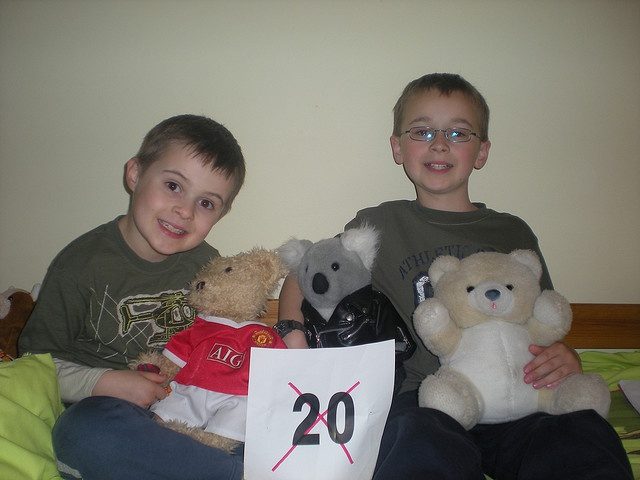Describe the objects in this image and their specific colors. I can see people in gray, black, and navy tones, people in gray and black tones, teddy bear in gray and darkgray tones, teddy bear in gray, brown, and darkgray tones, and teddy bear in gray, black, and darkgray tones in this image. 